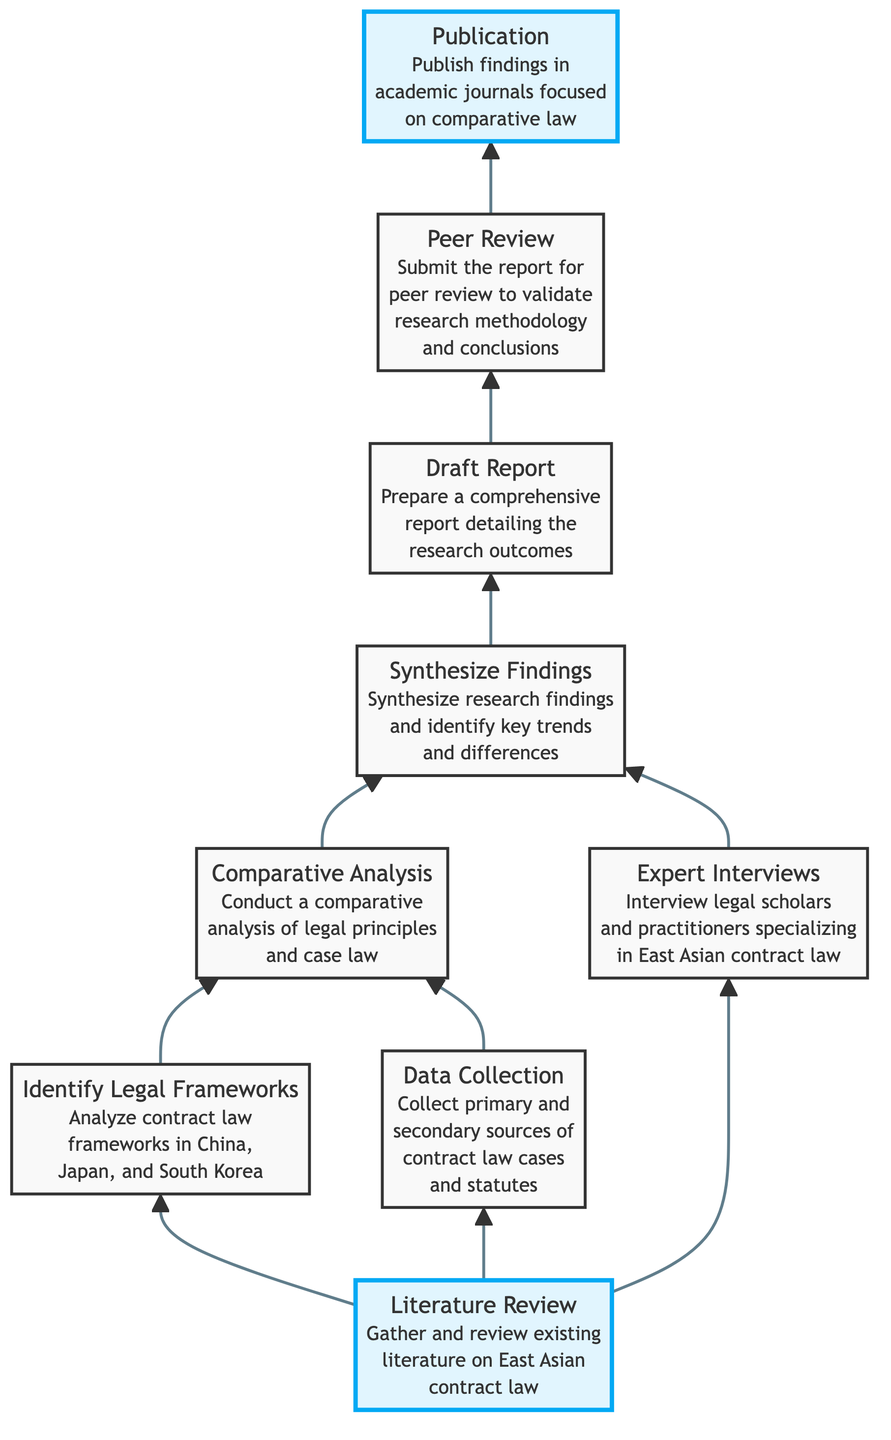What is the first step in the legal research process? The first step is "Literature Review," which is indicated at the top of the diagram as the initial node.
Answer: Literature Review How many nodes are there in the diagram? By counting the nodes represented in the diagram, there are nine distinct elements related to the legal research process.
Answer: 9 What nodes directly connect to "Comparative Analysis"? The nodes that lead to "Comparative Analysis" are "Identify Legal Frameworks" and "Data Collection," both of which are directly linked to it in the flowchart.
Answer: Identify Legal Frameworks, Data Collection What is the final step in the legal research process? The final step is "Publication," located at the bottom of the diagram, showing it as the concluding action after "Peer Review."
Answer: Publication List the second step in the diagram. The second step is "Identify Legal Frameworks," which follows the initial step of "Literature Review."
Answer: Identify Legal Frameworks What do "Expert Interviews" contribute to in the research process? "Expert Interviews" contribute to "Synthesize Findings," as they directly link to this step, indicating their role in refining the research outcomes.
Answer: Synthesize Findings Which two nodes are required before drafting the report? Before drafting the report, the steps "Comparative Analysis" and "Synthesize Findings" must be completed, as indicated by the flow of the diagram leading to "Draft Report."
Answer: Comparative Analysis, Synthesize Findings Why is "Peer Review" important in the research process? "Peer Review" is crucial because it validates the research methodology and conclusions before publication, as shown by its position just before "Publication" in the diagram.
Answer: Validates research methodology and conclusions How many steps precede the "Draft Report" node? There are three steps that precede "Draft Report": "Comparative Analysis," "Expert Interviews," and "Synthesize Findings," forming a clear path to this node.
Answer: 3 